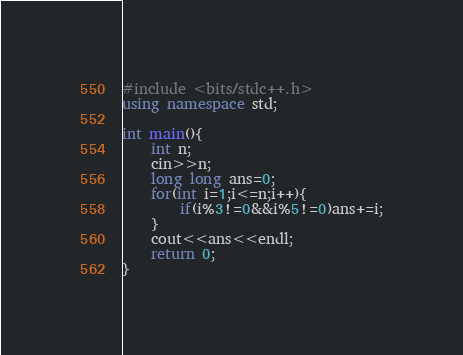<code> <loc_0><loc_0><loc_500><loc_500><_C++_>#include <bits/stdc++.h>
using namespace std;

int main(){
    int n;
    cin>>n;
    long long ans=0;
    for(int i=1;i<=n;i++){
    	if(i%3!=0&&i%5!=0)ans+=i;
	}
	cout<<ans<<endl;
	return 0;
}
</code> 